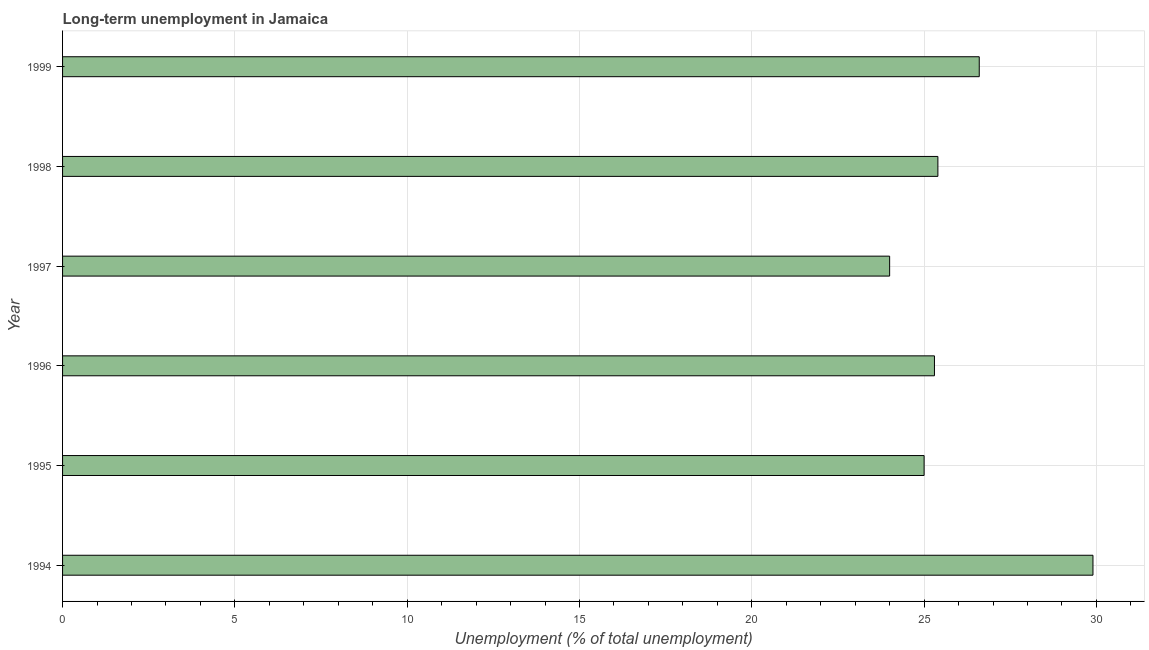Does the graph contain grids?
Provide a short and direct response. Yes. What is the title of the graph?
Provide a succinct answer. Long-term unemployment in Jamaica. What is the label or title of the X-axis?
Keep it short and to the point. Unemployment (% of total unemployment). What is the long-term unemployment in 1994?
Your answer should be compact. 29.9. Across all years, what is the maximum long-term unemployment?
Offer a terse response. 29.9. In which year was the long-term unemployment maximum?
Your response must be concise. 1994. What is the sum of the long-term unemployment?
Give a very brief answer. 156.2. What is the average long-term unemployment per year?
Offer a terse response. 26.03. What is the median long-term unemployment?
Offer a terse response. 25.35. Do a majority of the years between 1999 and 1994 (inclusive) have long-term unemployment greater than 15 %?
Give a very brief answer. Yes. What is the ratio of the long-term unemployment in 1997 to that in 1999?
Provide a short and direct response. 0.9. Is the difference between the long-term unemployment in 1997 and 1999 greater than the difference between any two years?
Ensure brevity in your answer.  No. Is the sum of the long-term unemployment in 1996 and 1997 greater than the maximum long-term unemployment across all years?
Offer a very short reply. Yes. What is the difference between the highest and the lowest long-term unemployment?
Provide a short and direct response. 5.9. In how many years, is the long-term unemployment greater than the average long-term unemployment taken over all years?
Your answer should be compact. 2. How many bars are there?
Your answer should be very brief. 6. How many years are there in the graph?
Make the answer very short. 6. Are the values on the major ticks of X-axis written in scientific E-notation?
Give a very brief answer. No. What is the Unemployment (% of total unemployment) of 1994?
Keep it short and to the point. 29.9. What is the Unemployment (% of total unemployment) in 1996?
Offer a terse response. 25.3. What is the Unemployment (% of total unemployment) in 1997?
Your response must be concise. 24. What is the Unemployment (% of total unemployment) of 1998?
Provide a succinct answer. 25.4. What is the Unemployment (% of total unemployment) in 1999?
Keep it short and to the point. 26.6. What is the difference between the Unemployment (% of total unemployment) in 1994 and 1995?
Give a very brief answer. 4.9. What is the difference between the Unemployment (% of total unemployment) in 1994 and 1998?
Provide a succinct answer. 4.5. What is the difference between the Unemployment (% of total unemployment) in 1995 and 1998?
Make the answer very short. -0.4. What is the difference between the Unemployment (% of total unemployment) in 1995 and 1999?
Give a very brief answer. -1.6. What is the difference between the Unemployment (% of total unemployment) in 1996 and 1997?
Offer a terse response. 1.3. What is the difference between the Unemployment (% of total unemployment) in 1996 and 1998?
Your response must be concise. -0.1. What is the difference between the Unemployment (% of total unemployment) in 1996 and 1999?
Provide a short and direct response. -1.3. What is the ratio of the Unemployment (% of total unemployment) in 1994 to that in 1995?
Provide a short and direct response. 1.2. What is the ratio of the Unemployment (% of total unemployment) in 1994 to that in 1996?
Ensure brevity in your answer.  1.18. What is the ratio of the Unemployment (% of total unemployment) in 1994 to that in 1997?
Provide a short and direct response. 1.25. What is the ratio of the Unemployment (% of total unemployment) in 1994 to that in 1998?
Keep it short and to the point. 1.18. What is the ratio of the Unemployment (% of total unemployment) in 1994 to that in 1999?
Offer a very short reply. 1.12. What is the ratio of the Unemployment (% of total unemployment) in 1995 to that in 1997?
Offer a very short reply. 1.04. What is the ratio of the Unemployment (% of total unemployment) in 1996 to that in 1997?
Ensure brevity in your answer.  1.05. What is the ratio of the Unemployment (% of total unemployment) in 1996 to that in 1999?
Offer a very short reply. 0.95. What is the ratio of the Unemployment (% of total unemployment) in 1997 to that in 1998?
Make the answer very short. 0.94. What is the ratio of the Unemployment (% of total unemployment) in 1997 to that in 1999?
Your answer should be compact. 0.9. What is the ratio of the Unemployment (% of total unemployment) in 1998 to that in 1999?
Keep it short and to the point. 0.95. 